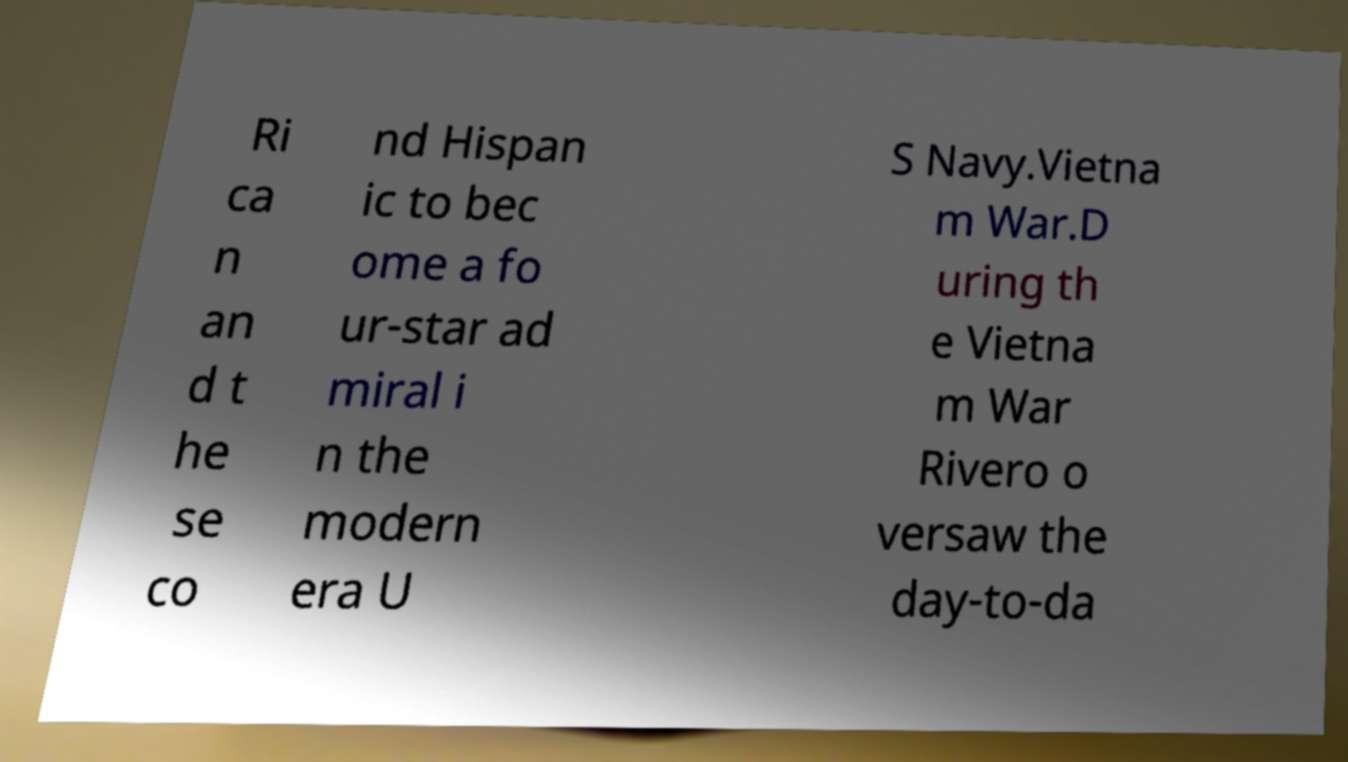Can you accurately transcribe the text from the provided image for me? Ri ca n an d t he se co nd Hispan ic to bec ome a fo ur-star ad miral i n the modern era U S Navy.Vietna m War.D uring th e Vietna m War Rivero o versaw the day-to-da 